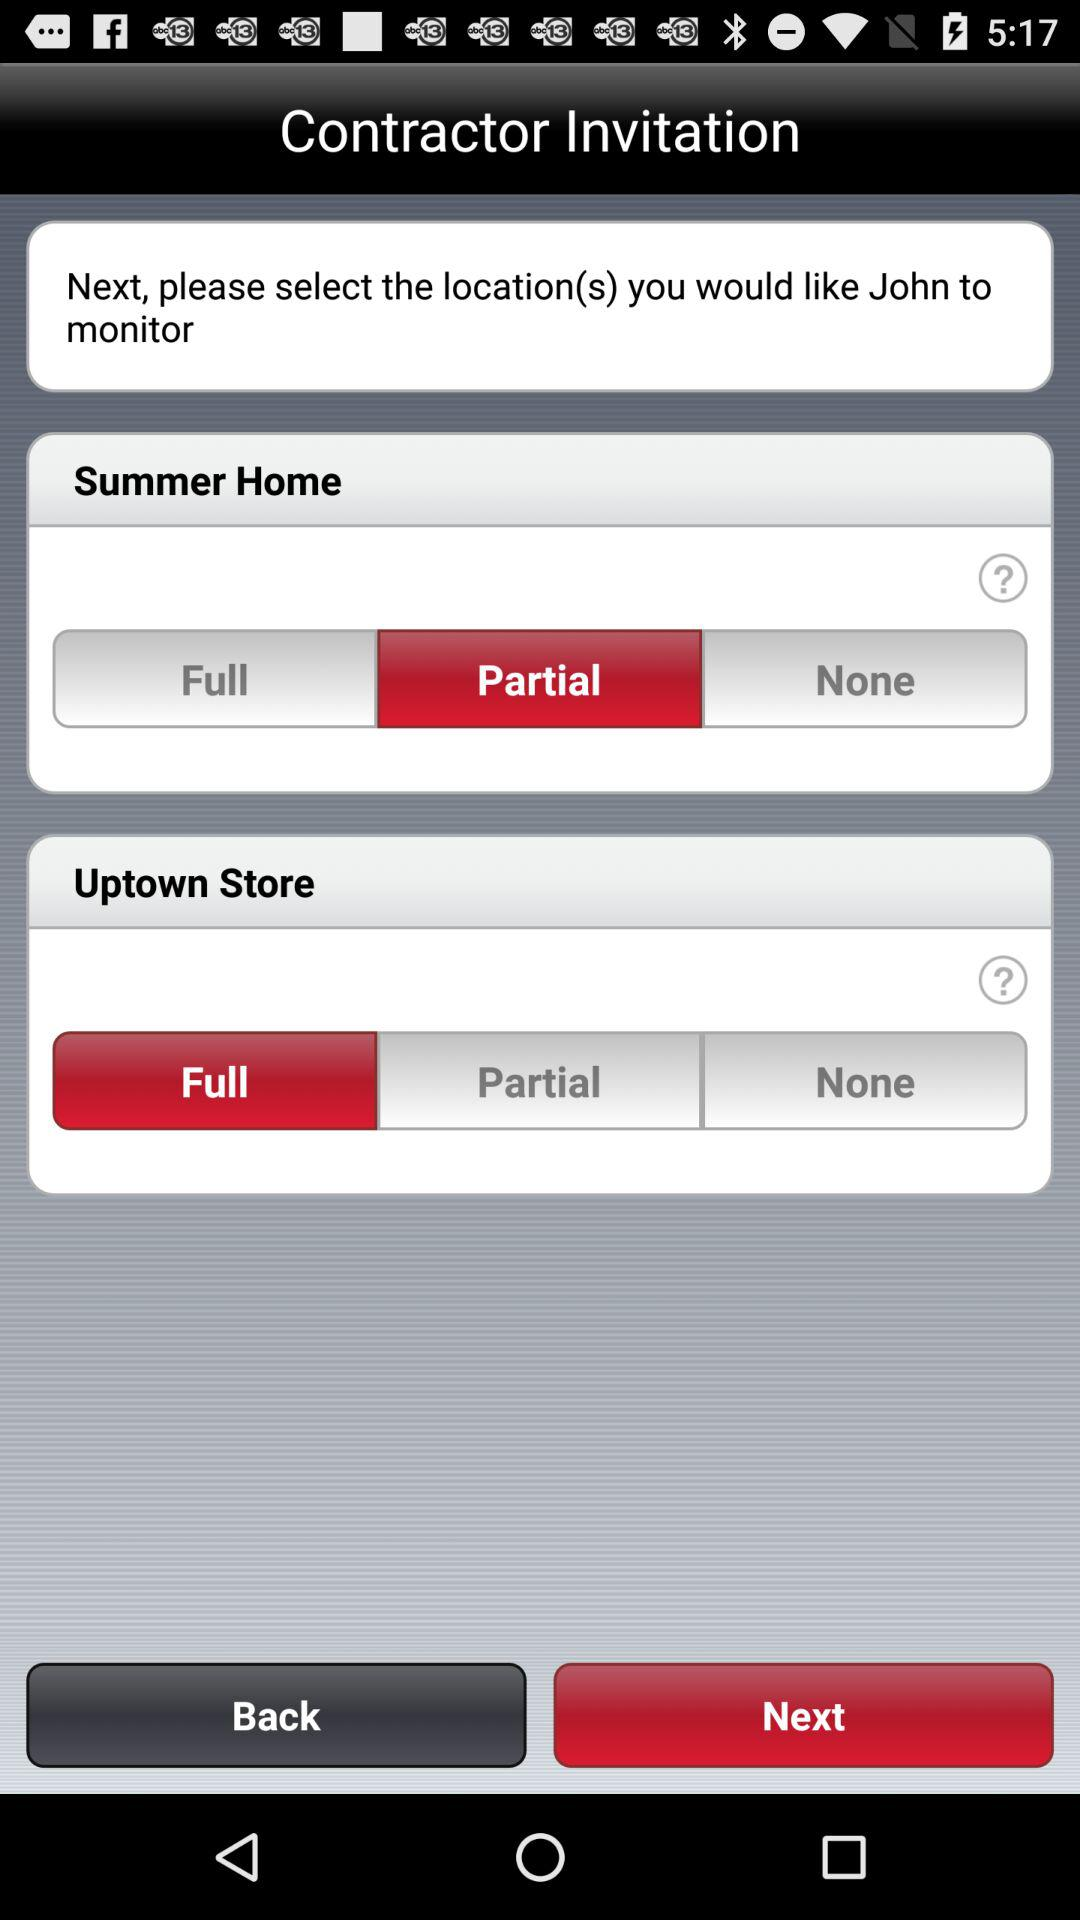When will John monitor the summer home?
When the provided information is insufficient, respond with <no answer>. <no answer> 